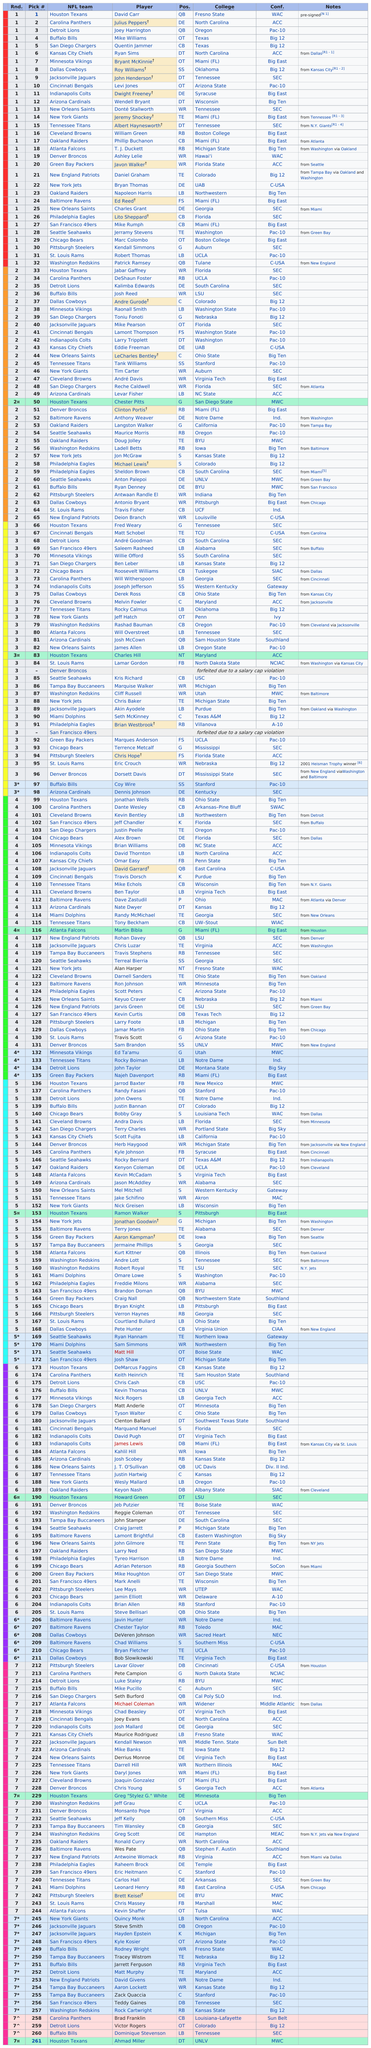Point out several critical features in this image. Atlanta had a total of seven draft picks. The Houston Texans had the first pick in the draft. The only position that San Diego drafted more than one of was wide receiver. The Houston Texans chose the first player in the National Football League (NFL) draft. A total of 25 players from the Big 12 conference were selected in the NFL Draft. 